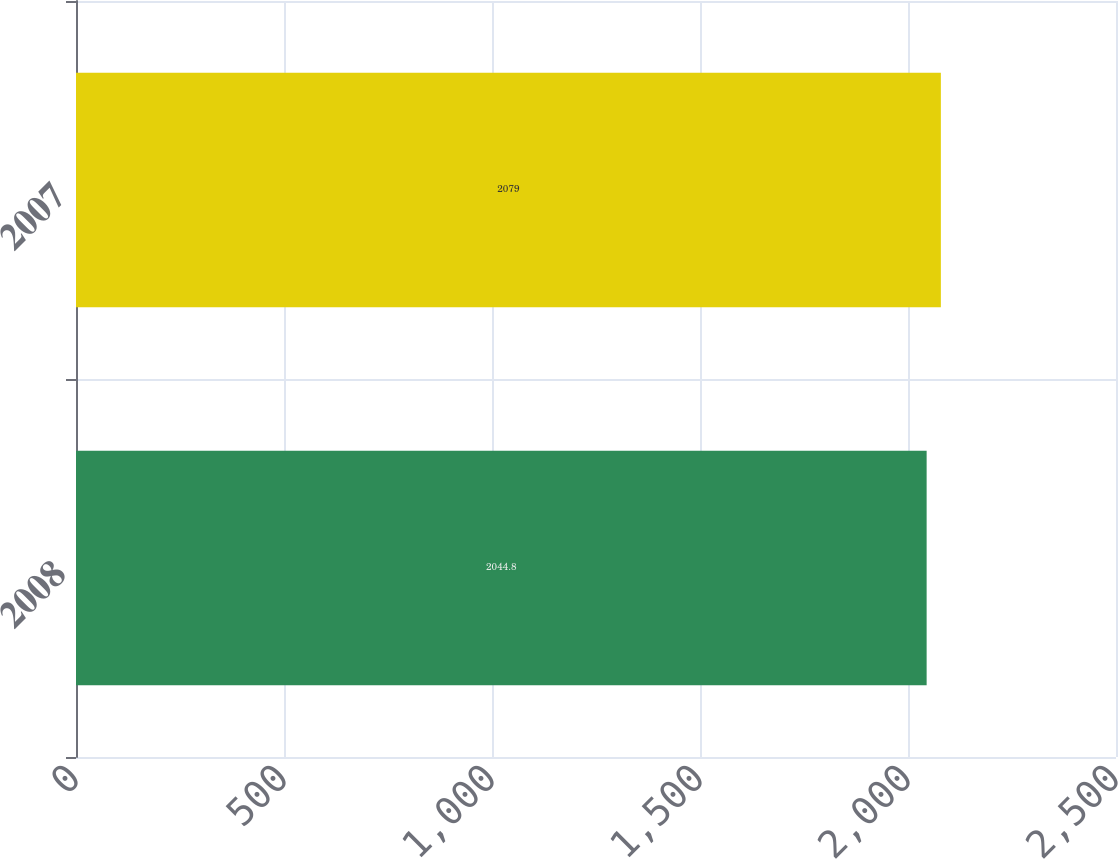Convert chart. <chart><loc_0><loc_0><loc_500><loc_500><bar_chart><fcel>2008<fcel>2007<nl><fcel>2044.8<fcel>2079<nl></chart> 